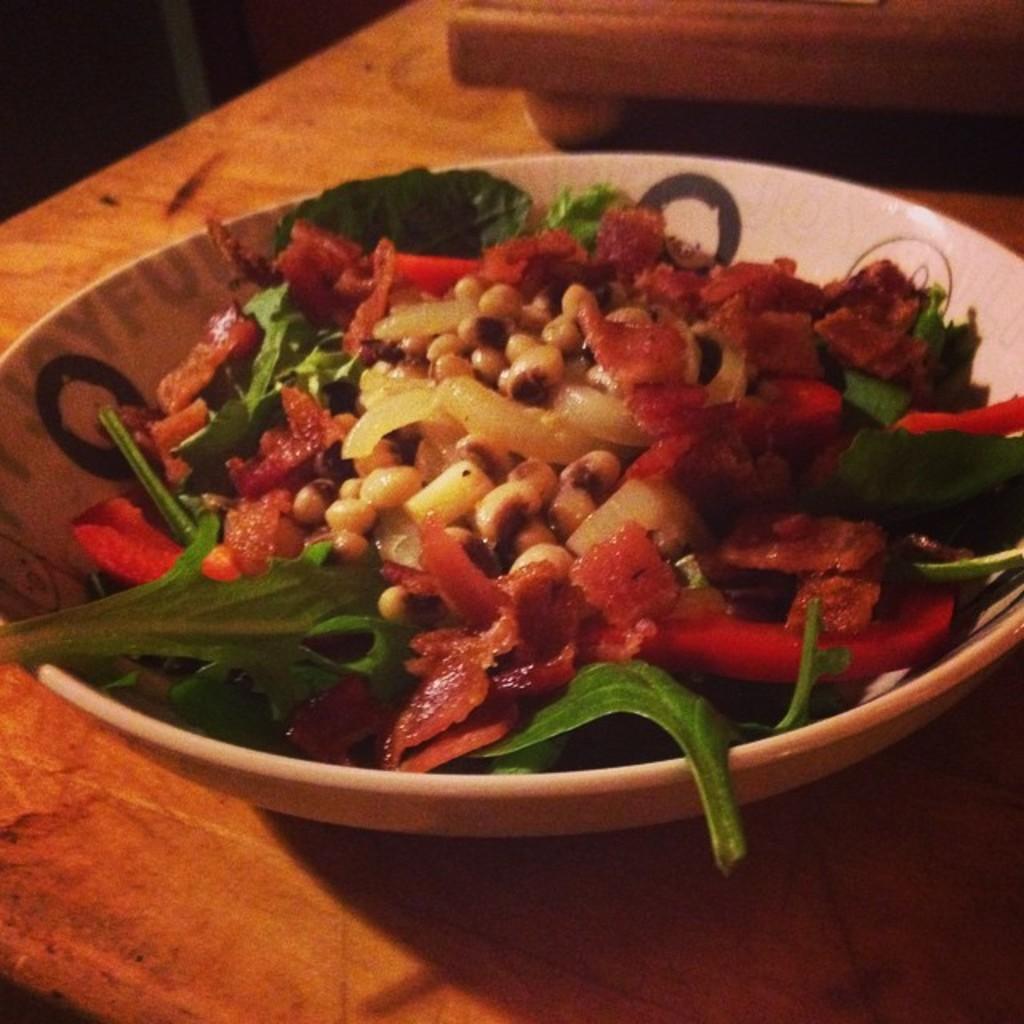Describe this image in one or two sentences. In the picture we can see a wooden table on it, we can see a bowl with a food item and some vegetable garnish on it. 